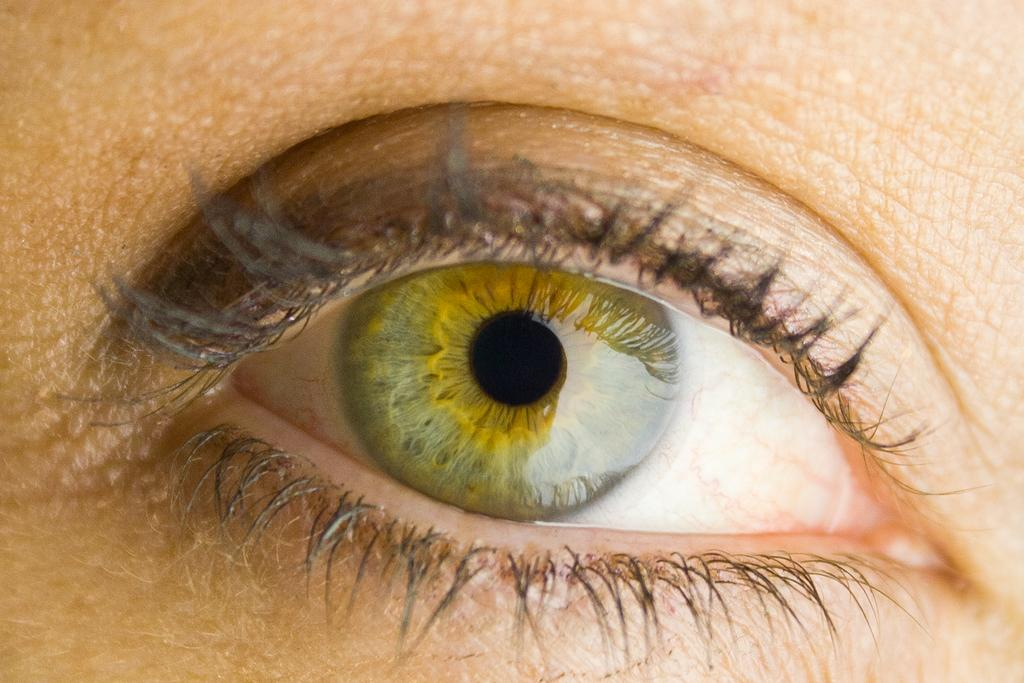What is the focus of the image? The image is zoomed in on the eye of a person. Can you describe the subject of the image in more detail? The image contains the eye of a person, which is the main subject. What type of feather can be seen in the image? There is no feather present in the image; it only contains the eye of a person. 